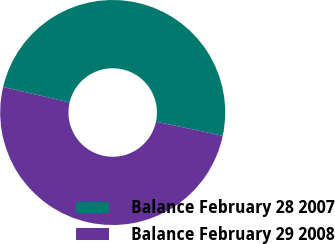<chart> <loc_0><loc_0><loc_500><loc_500><pie_chart><fcel>Balance February 28 2007<fcel>Balance February 29 2008<nl><fcel>49.68%<fcel>50.32%<nl></chart> 